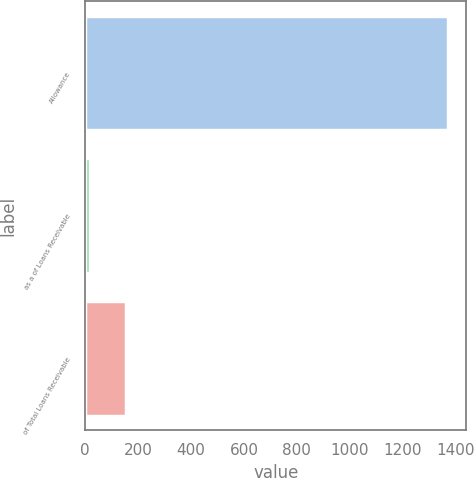Convert chart. <chart><loc_0><loc_0><loc_500><loc_500><bar_chart><fcel>Allowance<fcel>as a of Loans Receivable<fcel>of Total Loans Receivable<nl><fcel>1372<fcel>18<fcel>153.4<nl></chart> 